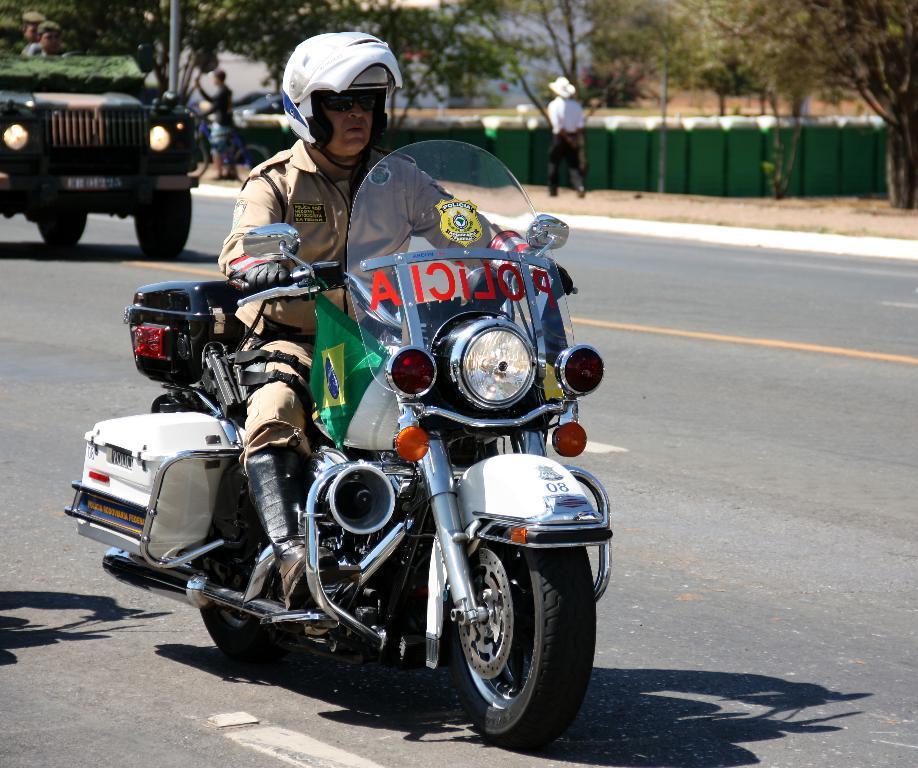In one or two sentences, can you explain what this image depicts? In this image, we can see a man riding a bike, he is wearing helmet, there is a car on the road, in the background there is a person walking and we can see some trees. 